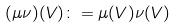<formula> <loc_0><loc_0><loc_500><loc_500>( \mu \nu ) ( V ) \colon = \mu ( V ) \nu ( V )</formula> 